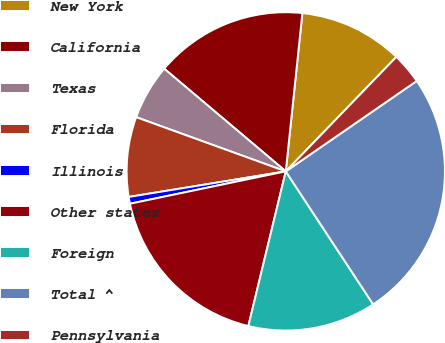Convert chart to OTSL. <chart><loc_0><loc_0><loc_500><loc_500><pie_chart><fcel>New York<fcel>California<fcel>Texas<fcel>Florida<fcel>Illinois<fcel>Other states<fcel>Foreign<fcel>Total ^<fcel>Pennsylvania<nl><fcel>10.56%<fcel>15.5%<fcel>5.63%<fcel>8.1%<fcel>0.69%<fcel>17.96%<fcel>13.03%<fcel>25.36%<fcel>3.16%<nl></chart> 